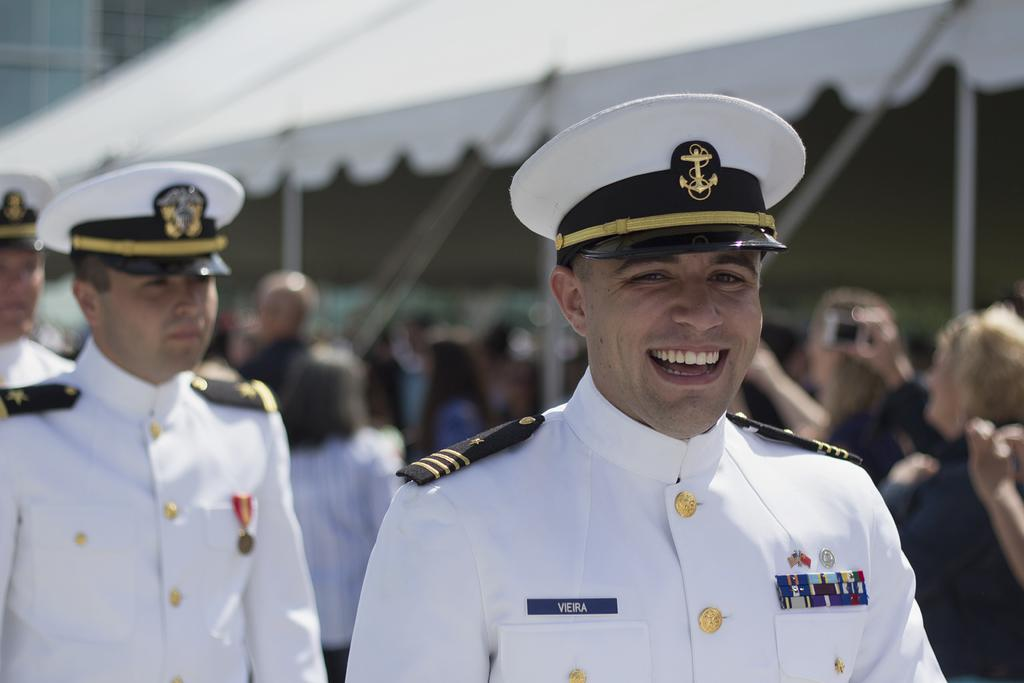How many people are standing in the image? There are three people standing in the image. What are the three people wearing? The three people are wearing hats. Can you describe the people in the background of the image? There is a group of people in the background of the image, and they are under a tent. What color is the sea visible in the background of the image? There is no sea visible in the background of the image. 